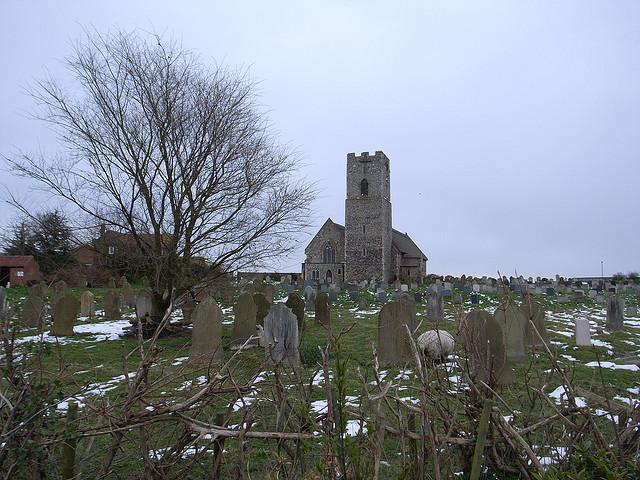Is this a field?
Write a very short answer. No. What material is the roof made of?
Short answer required. Stone. Are there leaves on the trees?
Quick response, please. No. Is this a graveyard?
Be succinct. Yes. Why are the sheep in a graveyard??
Concise answer only. Grazing. What is the weather?
Concise answer only. Clear. 